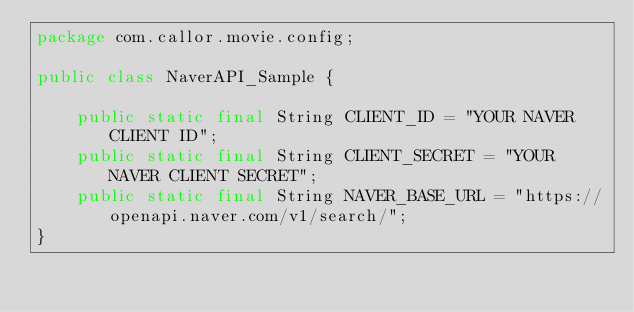Convert code to text. <code><loc_0><loc_0><loc_500><loc_500><_Java_>package com.callor.movie.config;

public class NaverAPI_Sample {

    public static final String CLIENT_ID = "YOUR NAVER CLIENT ID";
    public static final String CLIENT_SECRET = "YOUR NAVER CLIENT SECRET";
    public static final String NAVER_BASE_URL = "https://openapi.naver.com/v1/search/";
}
</code> 